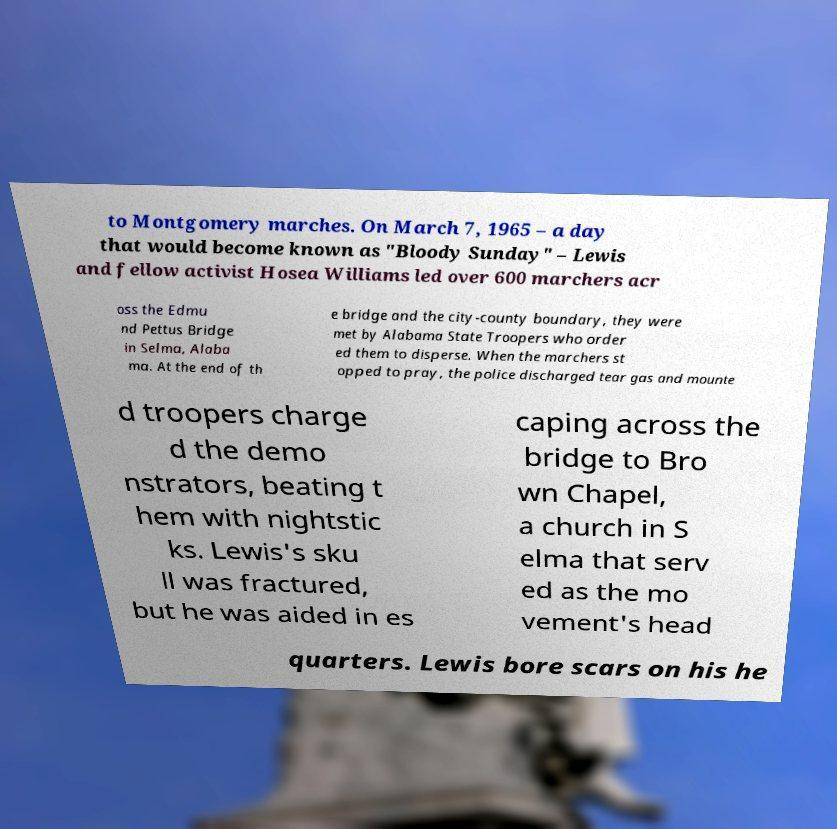There's text embedded in this image that I need extracted. Can you transcribe it verbatim? to Montgomery marches. On March 7, 1965 – a day that would become known as "Bloody Sunday" – Lewis and fellow activist Hosea Williams led over 600 marchers acr oss the Edmu nd Pettus Bridge in Selma, Alaba ma. At the end of th e bridge and the city-county boundary, they were met by Alabama State Troopers who order ed them to disperse. When the marchers st opped to pray, the police discharged tear gas and mounte d troopers charge d the demo nstrators, beating t hem with nightstic ks. Lewis's sku ll was fractured, but he was aided in es caping across the bridge to Bro wn Chapel, a church in S elma that serv ed as the mo vement's head quarters. Lewis bore scars on his he 